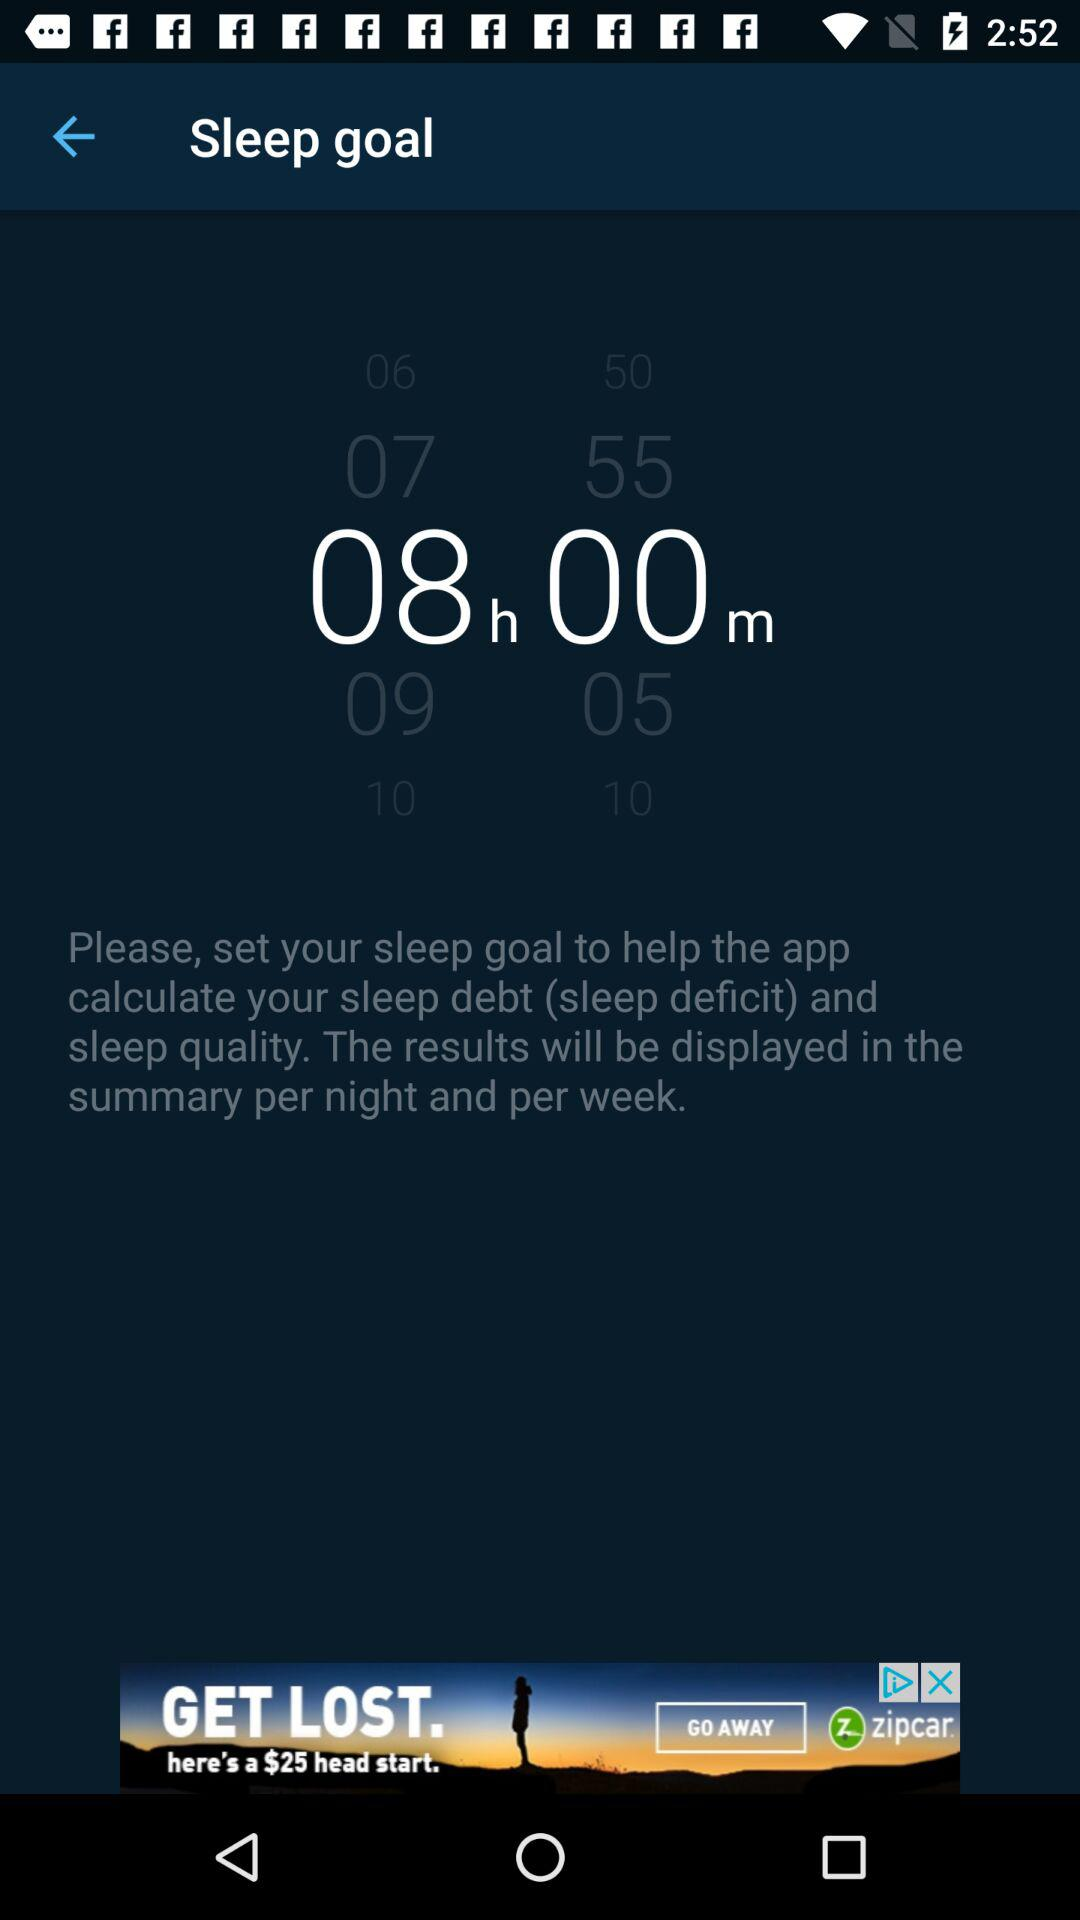What time duration is set for the sleep goal? The time duration set for the sleep goal is 8 hours. 